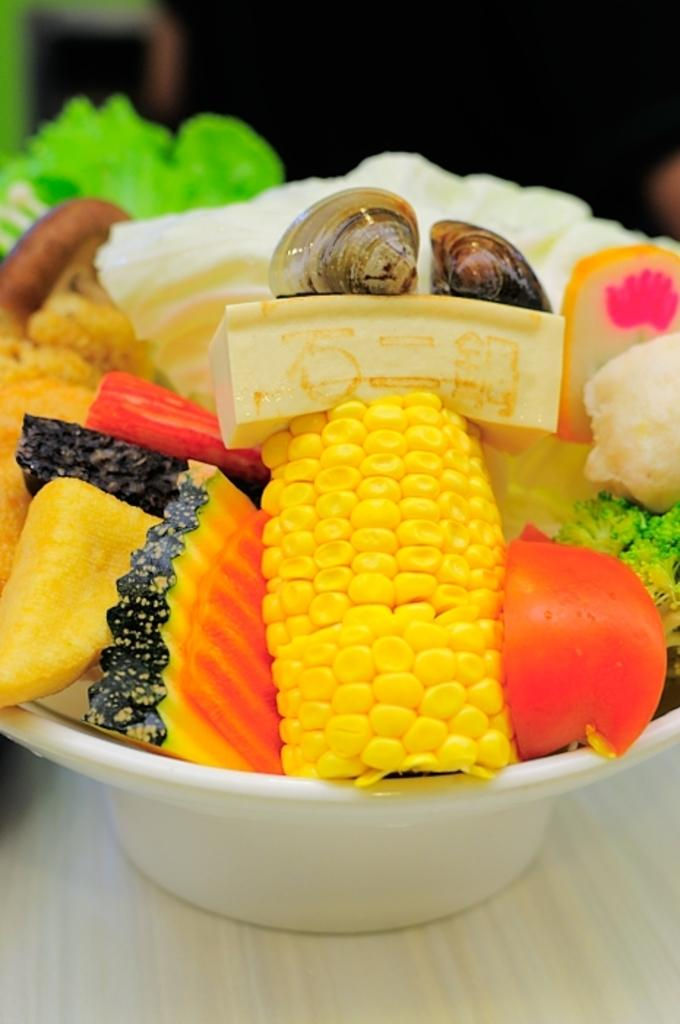What types of food items can be seen in the image? There are eatable things in the image, including vegetables in a white bowl. Can you describe the bowl in the image? The white bowl contains vegetables and is placed on a wooden surface. What color is the bowl in the image? The bowl is white. What color is visible at the top of the image? There is black color visible at the top of the image. How many flowers are present in the image? There are no flowers visible in the image. What type of lettuce is being used as a tablecloth in the image? There is no lettuce being used as a tablecloth in the image. 